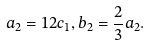Convert formula to latex. <formula><loc_0><loc_0><loc_500><loc_500>a _ { 2 } = 1 2 c _ { 1 } , b _ { 2 } = \frac { 2 } { 3 } a _ { 2 } .</formula> 